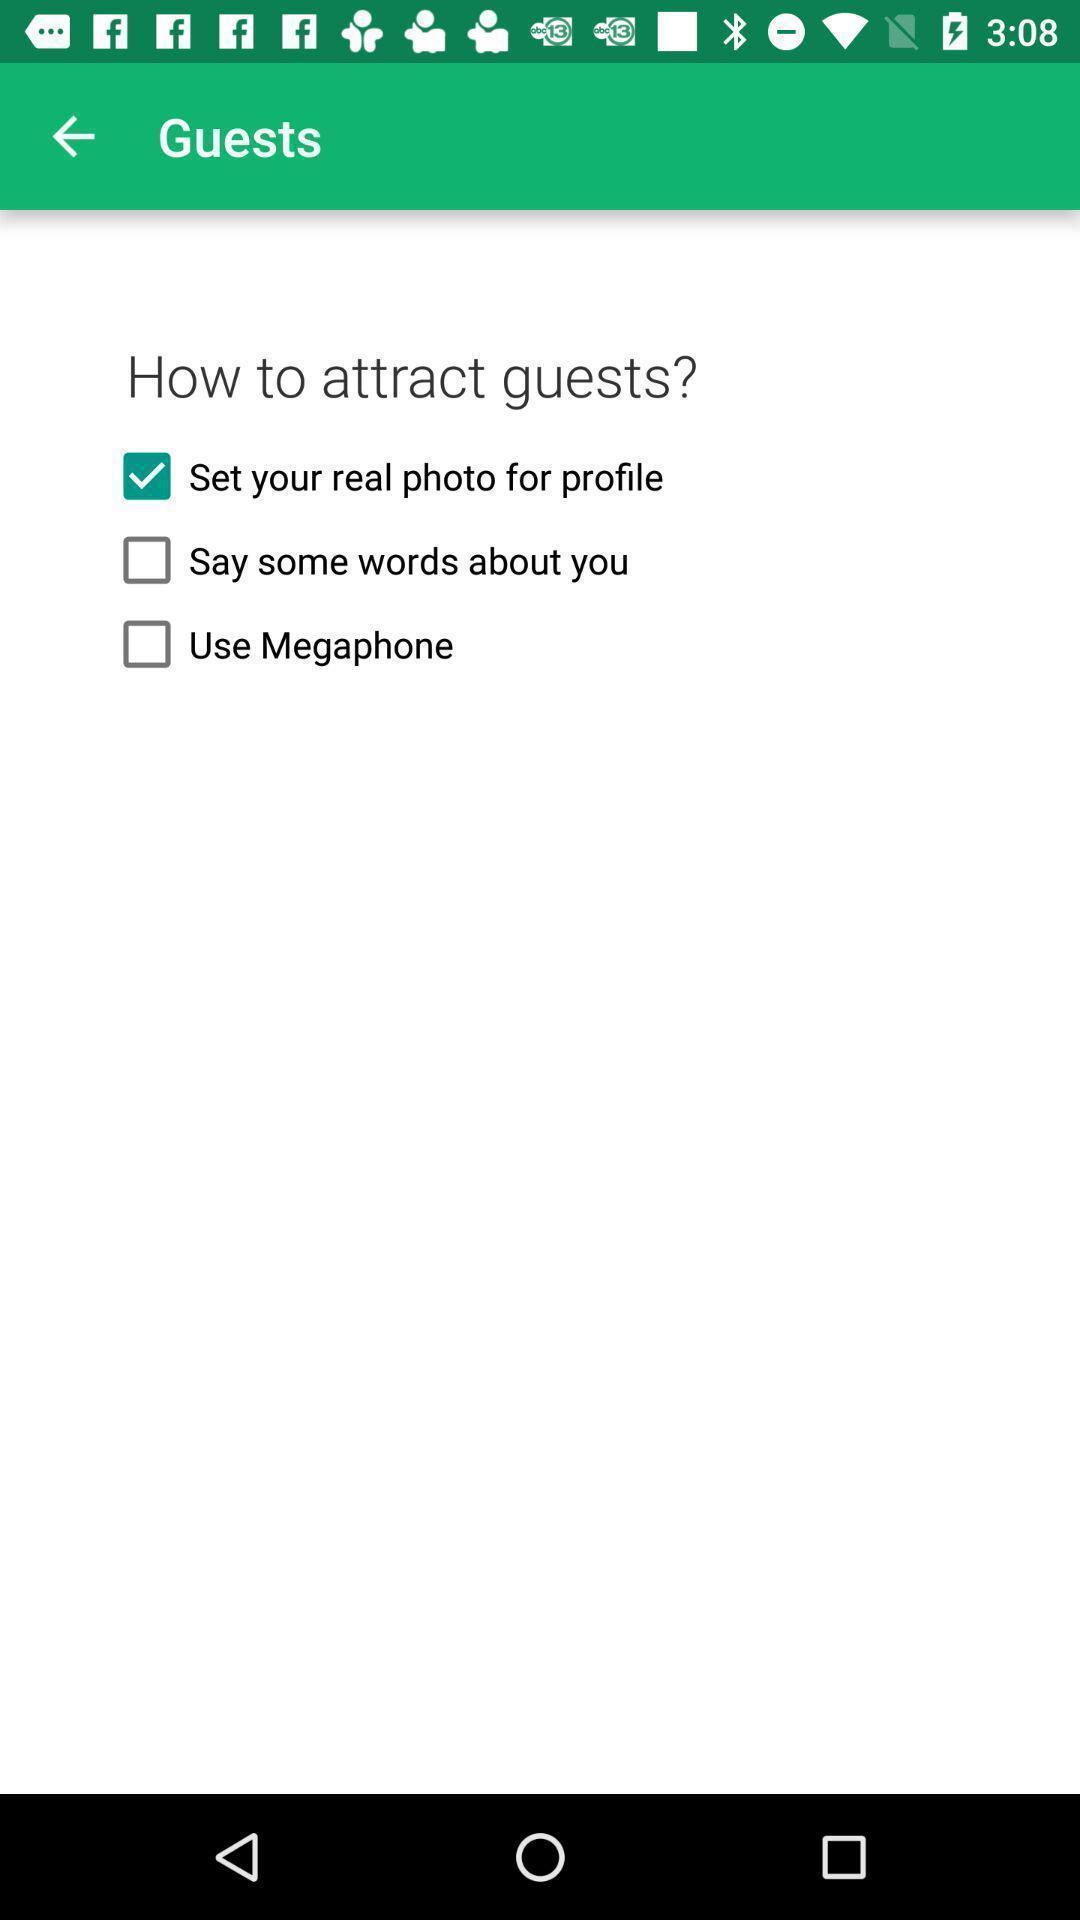Describe the visual elements of this screenshot. Screen showing how to attract guests. 